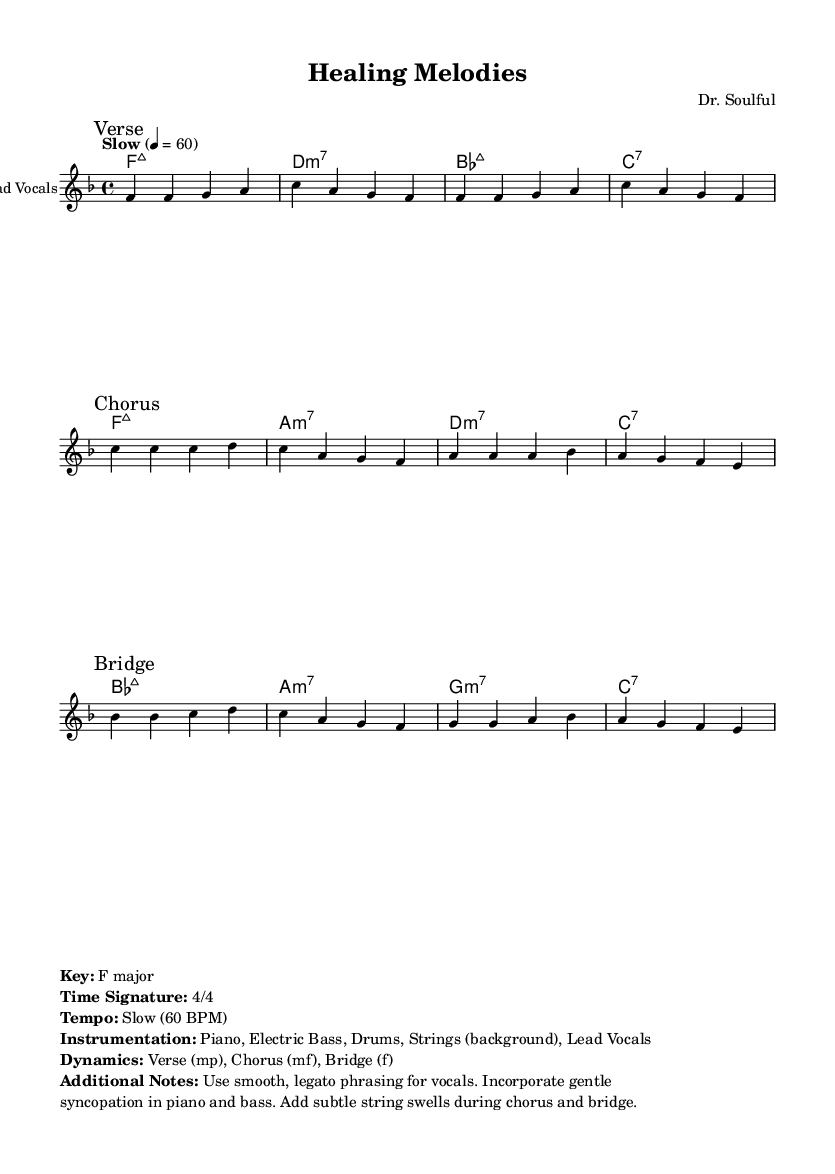What is the key signature of this music? The key signature is F major, which has one flat (B flat).
Answer: F major What is the time signature of the piece? The time signature is 4/4, indicating four beats per measure.
Answer: 4/4 What is the tempo marking for this composition? The tempo marking indicates a slow tempo of 60 beats per minute, which suggests a relaxed and gentle feel.
Answer: Slow (60 BPM) What are the dynamics in the chorus? The dynamics in the chorus are marked as mf, which stands for mezzo-forte, indicating a moderately loud volume.
Answer: mf How many measures are in the verse section? The verse section consists of 8 measures, as evidenced by the repeated phrases without any breaks or pauses.
Answer: 8 What type of chords are used in the bridge section? The bridge section utilizes major seventh and minor seventh chords, creating a rich harmonic texture typical in R&B.
Answer: Major seventh and minor seventh Why might the use of legato phrasing be important for this genre? Legato phrasing emphasizes smooth transitions between notes, which enhances the emotional delivery and expressive qualities characteristic of Rhythm and Blues.
Answer: Emotional delivery 